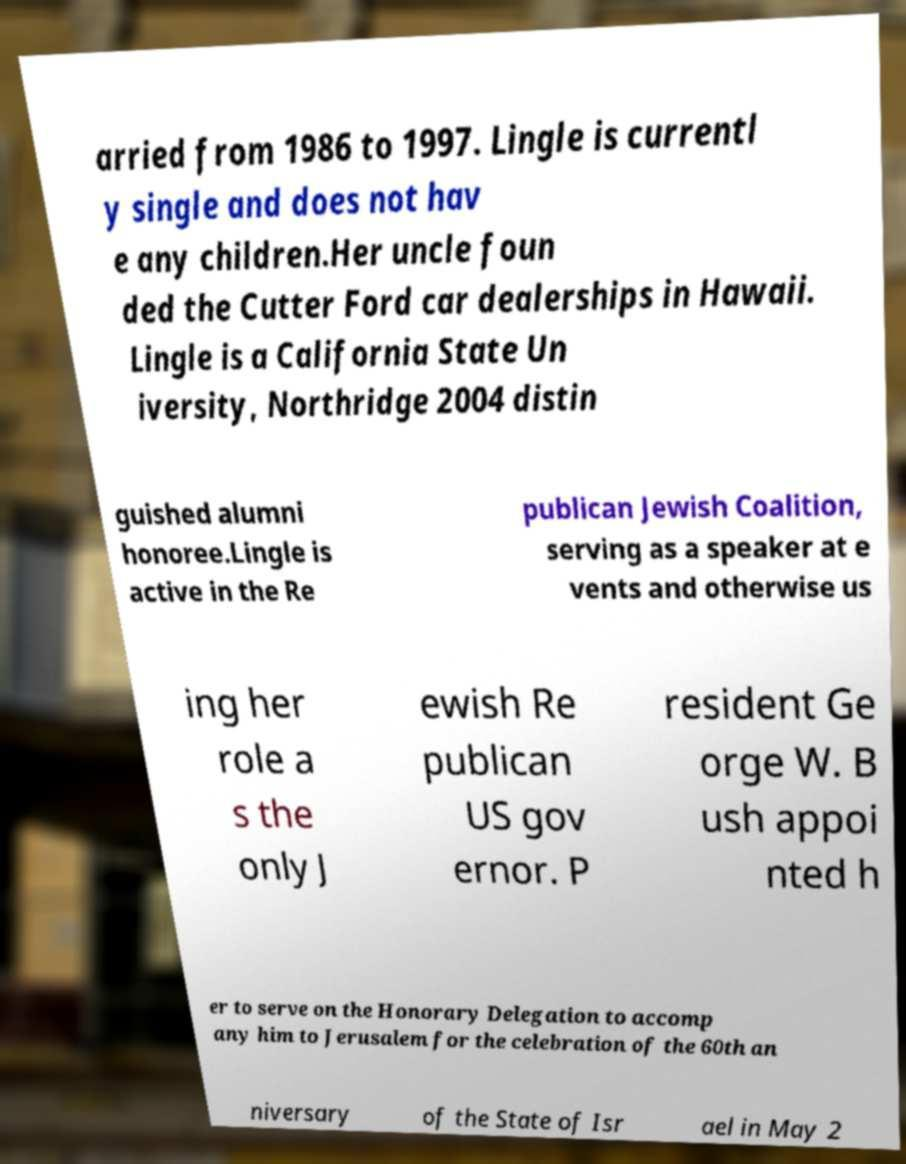Could you assist in decoding the text presented in this image and type it out clearly? arried from 1986 to 1997. Lingle is currentl y single and does not hav e any children.Her uncle foun ded the Cutter Ford car dealerships in Hawaii. Lingle is a California State Un iversity, Northridge 2004 distin guished alumni honoree.Lingle is active in the Re publican Jewish Coalition, serving as a speaker at e vents and otherwise us ing her role a s the only J ewish Re publican US gov ernor. P resident Ge orge W. B ush appoi nted h er to serve on the Honorary Delegation to accomp any him to Jerusalem for the celebration of the 60th an niversary of the State of Isr ael in May 2 